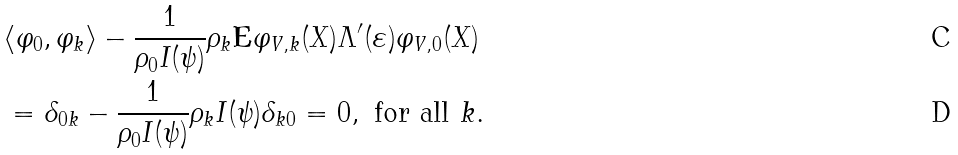<formula> <loc_0><loc_0><loc_500><loc_500>& \langle \varphi _ { 0 } , \varphi _ { k } \rangle - \frac { 1 } { \rho _ { 0 } I ( \psi ) } \rho _ { k } \mathbf E \varphi _ { V , k } ( X ) \Lambda ^ { \prime } ( \varepsilon ) \varphi _ { V , 0 } ( X ) \\ & = \delta _ { 0 k } - \frac { 1 } { \rho _ { 0 } I ( \psi ) } \rho _ { k } I ( \psi ) \delta _ { k 0 } = 0 , \text { for all } k .</formula> 